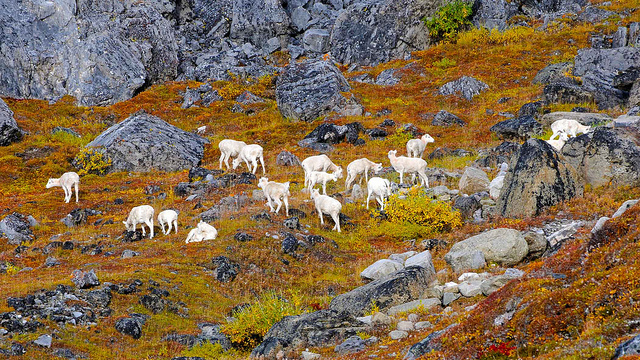How many animals are laying down? In this vibrant landscape, there are two animals that appear to be comfortably laying down, amidst the terrain embellished with autumn hues. 